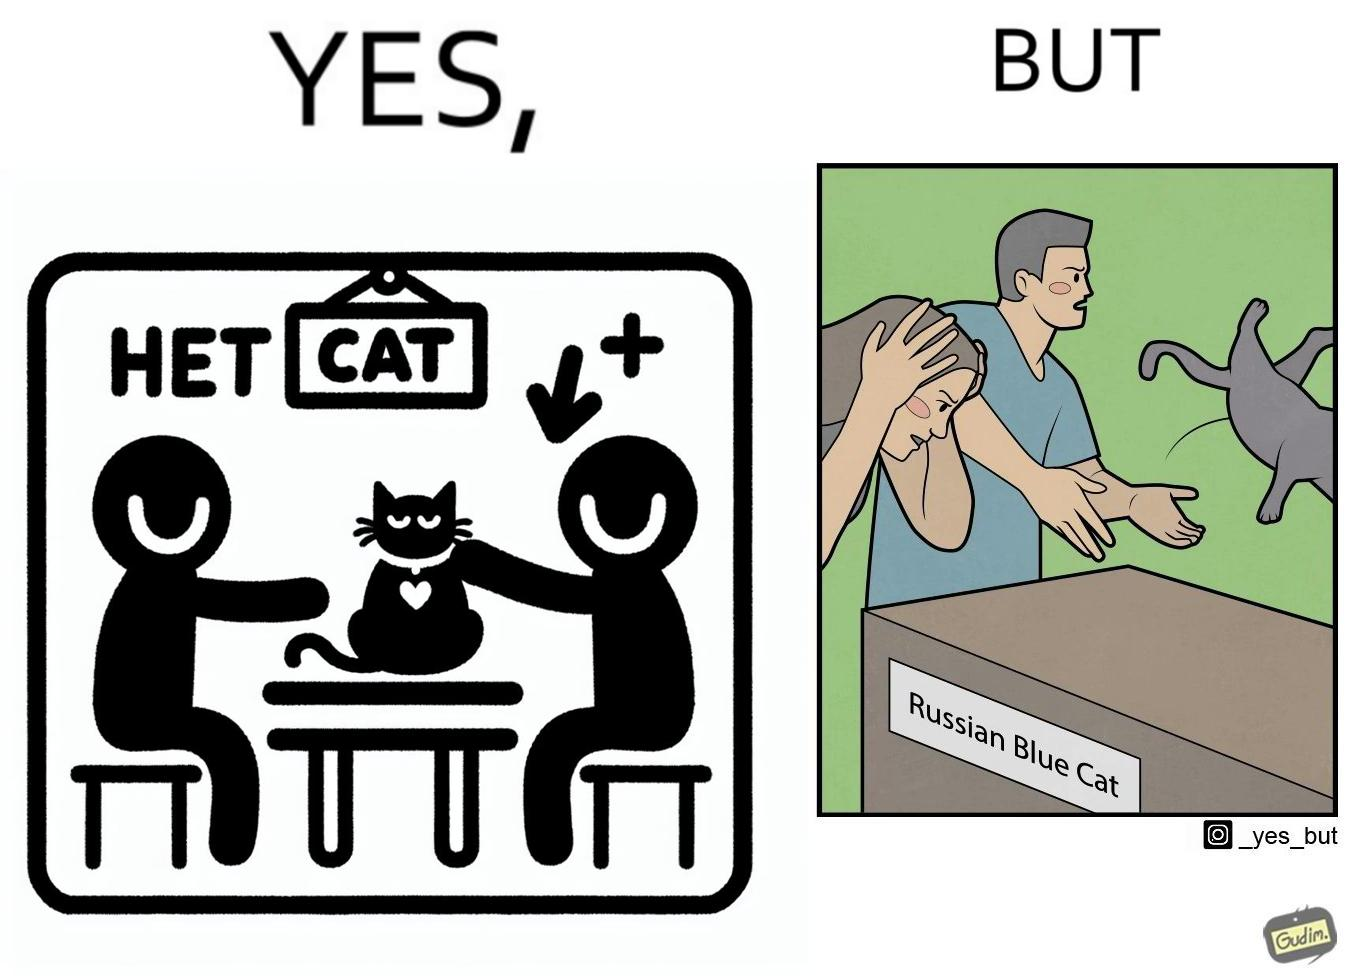What is shown in the left half versus the right half of this image? In the left part of the image: two happy people, where one of them is petting a cat sitting on a table, with a label "Blue Cat" written on the tabel. In the right part of the image: a worried person with hands on her head looking at a table with the label "Russian Blue Cat", while another angry person seems to be throwing away a cat. 